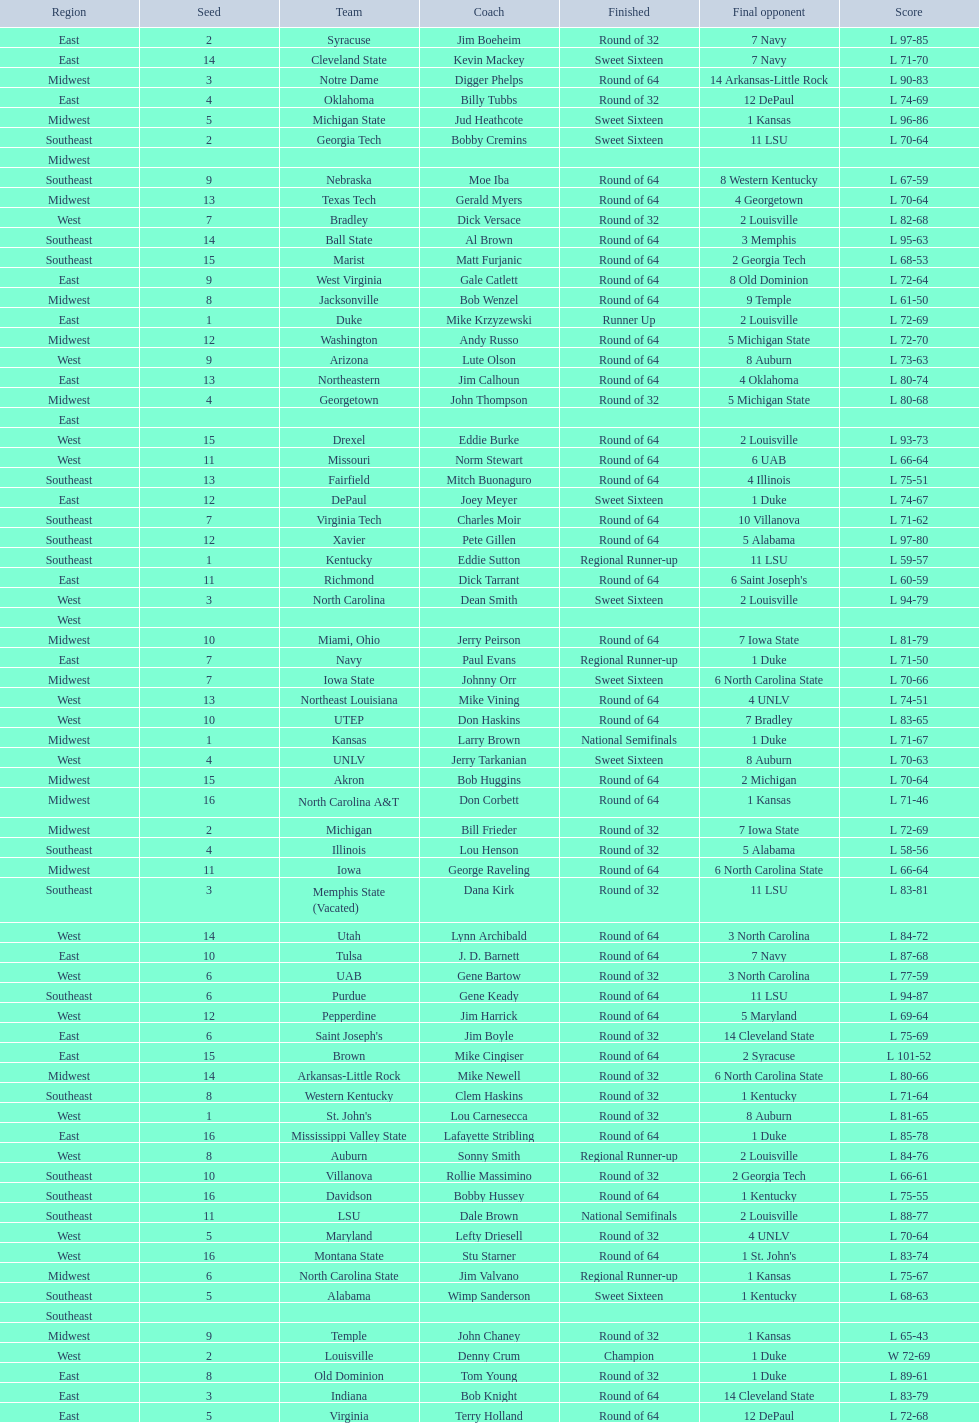Who was the only champion? Louisville. 